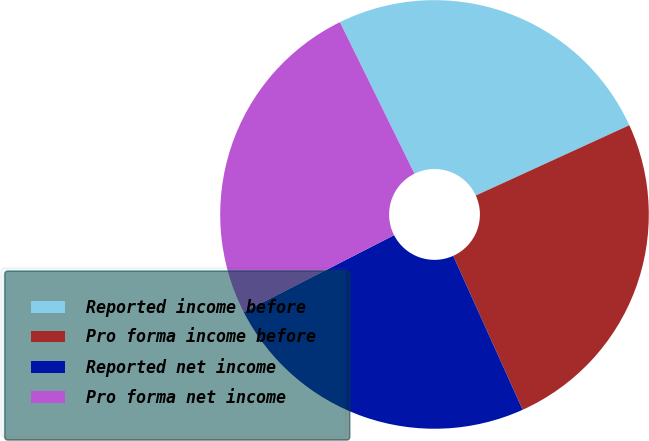<chart> <loc_0><loc_0><loc_500><loc_500><pie_chart><fcel>Reported income before<fcel>Pro forma income before<fcel>Reported net income<fcel>Pro forma net income<nl><fcel>25.44%<fcel>25.09%<fcel>24.21%<fcel>25.26%<nl></chart> 